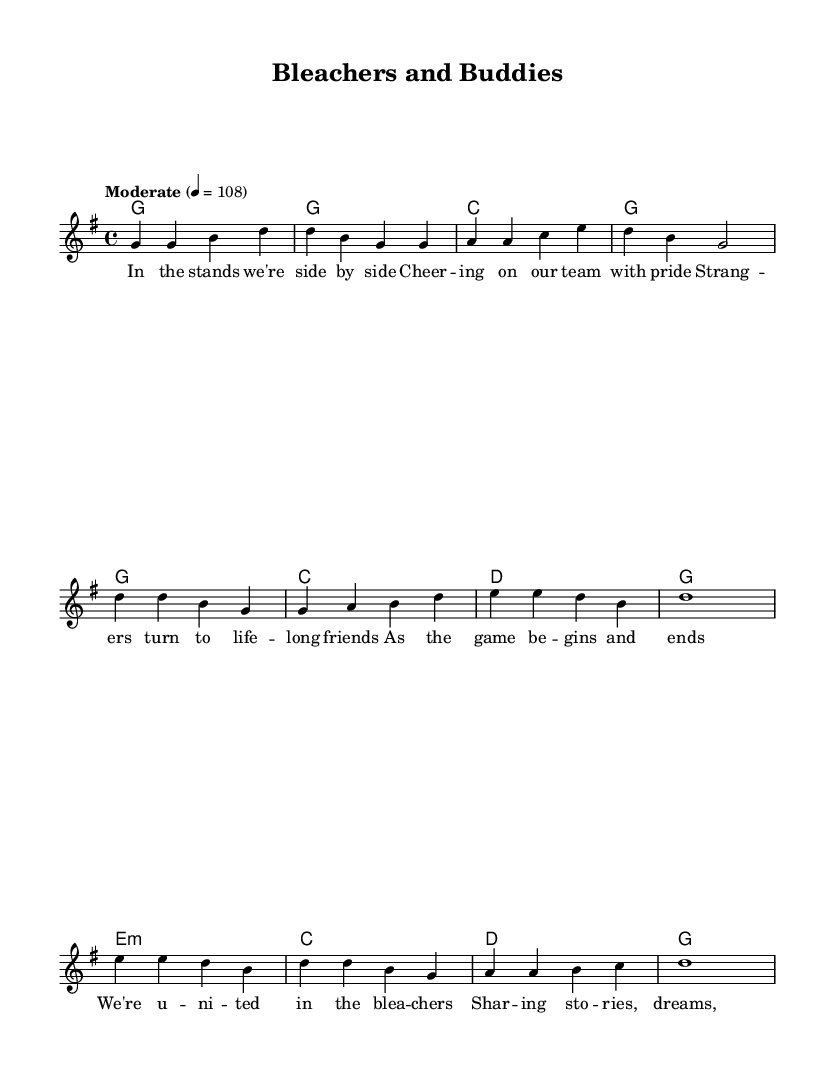What is the key signature of this music? The key signature is G major, which has one sharp (F#). This can be identified by looking at the key signature indication at the beginning of the score.
Answer: G major What is the time signature of this music? The time signature is 4/4, which indicates that there are four beats in each measure and the quarter note receives one beat. This is shown at the beginning of the score next to the key signature.
Answer: 4/4 What is the tempo marking of this piece? The tempo marking shows "Moderate" with a metronome marking of 108. This indicates the speed at which the music should be played, revealed in the tempo indication at the beginning of the piece.
Answer: Moderate 4 = 108 How many measures are in the chorus section? The chorus consists of four measures, as indicated by the grouping of the musical notation that shows the four sequential measures of melody and harmony.
Answer: 4 What is the main theme of the lyrics? The lyrics emphasize camaraderie among sports fans and the friendships that form during games. This can be inferred from the repeated expressions of support and unity among fans in the lyrics.
Answer: Camaraderie What chords are used in the bridge? The chords in the bridge are E minor, C, D, and G. This can be determined by examining the chord symbols beneath the melodic notes in the bridge section of the score.
Answer: E minor, C, D, G Which musical element highlights the friendship theme in this piece? The lyrics in the chorus highlight the theme of friendship, specifically mentioning sharing stories and dreams among fans, which conveys the sense of unity and bond that is central to the song's message.
Answer: Lyrics 